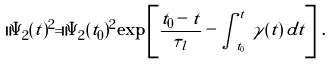<formula> <loc_0><loc_0><loc_500><loc_500>\| \Psi _ { 2 } ( t ) ^ { 2 } = \| \Psi _ { 2 } ( t _ { 0 } ) ^ { 2 } \exp \left [ \frac { t _ { 0 } - t } { \tau _ { l } } - \int _ { t _ { 0 } } ^ { t } \, \gamma ( t ) \, d t \right ] \, .</formula> 